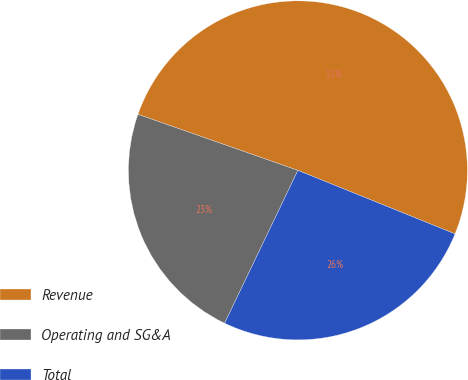Convert chart to OTSL. <chart><loc_0><loc_0><loc_500><loc_500><pie_chart><fcel>Revenue<fcel>Operating and SG&A<fcel>Total<nl><fcel>50.75%<fcel>23.25%<fcel>26.0%<nl></chart> 